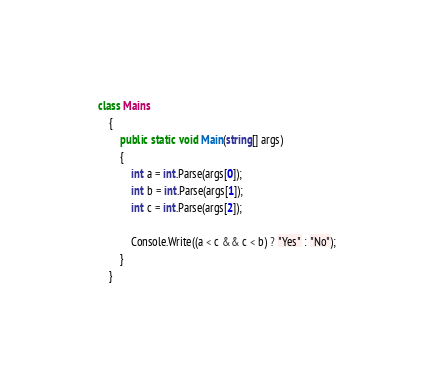<code> <loc_0><loc_0><loc_500><loc_500><_C#_>class Mains
    {
        public static void Main(string[] args)
        {
            int a = int.Parse(args[0]);
            int b = int.Parse(args[1]);
            int c = int.Parse(args[2]);

            Console.Write((a < c && c < b) ? "Yes" : "No");
        }
    }</code> 